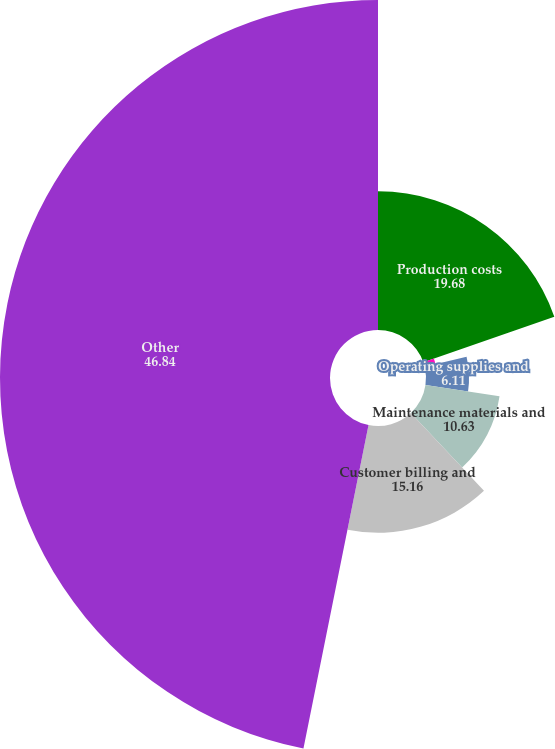Convert chart to OTSL. <chart><loc_0><loc_0><loc_500><loc_500><pie_chart><fcel>Production costs<fcel>Employee-related costs<fcel>Operating supplies and<fcel>Maintenance materials and<fcel>Customer billing and<fcel>Other<nl><fcel>19.68%<fcel>1.58%<fcel>6.11%<fcel>10.63%<fcel>15.16%<fcel>46.84%<nl></chart> 